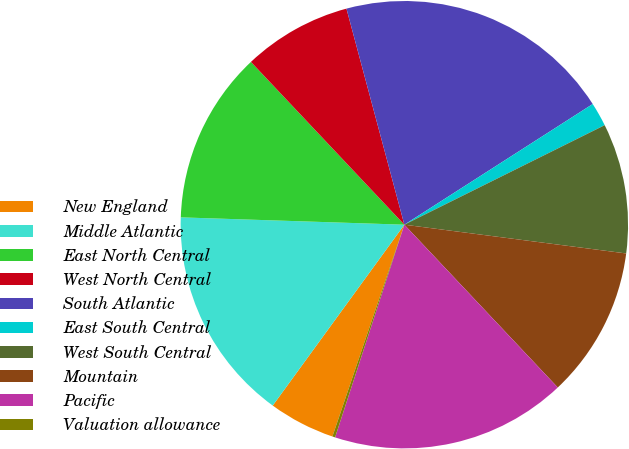Convert chart to OTSL. <chart><loc_0><loc_0><loc_500><loc_500><pie_chart><fcel>New England<fcel>Middle Atlantic<fcel>East North Central<fcel>West North Central<fcel>South Atlantic<fcel>East South Central<fcel>West South Central<fcel>Mountain<fcel>Pacific<fcel>Valuation allowance<nl><fcel>4.8%<fcel>15.51%<fcel>12.45%<fcel>7.86%<fcel>20.1%<fcel>1.73%<fcel>9.39%<fcel>10.92%<fcel>17.04%<fcel>0.2%<nl></chart> 